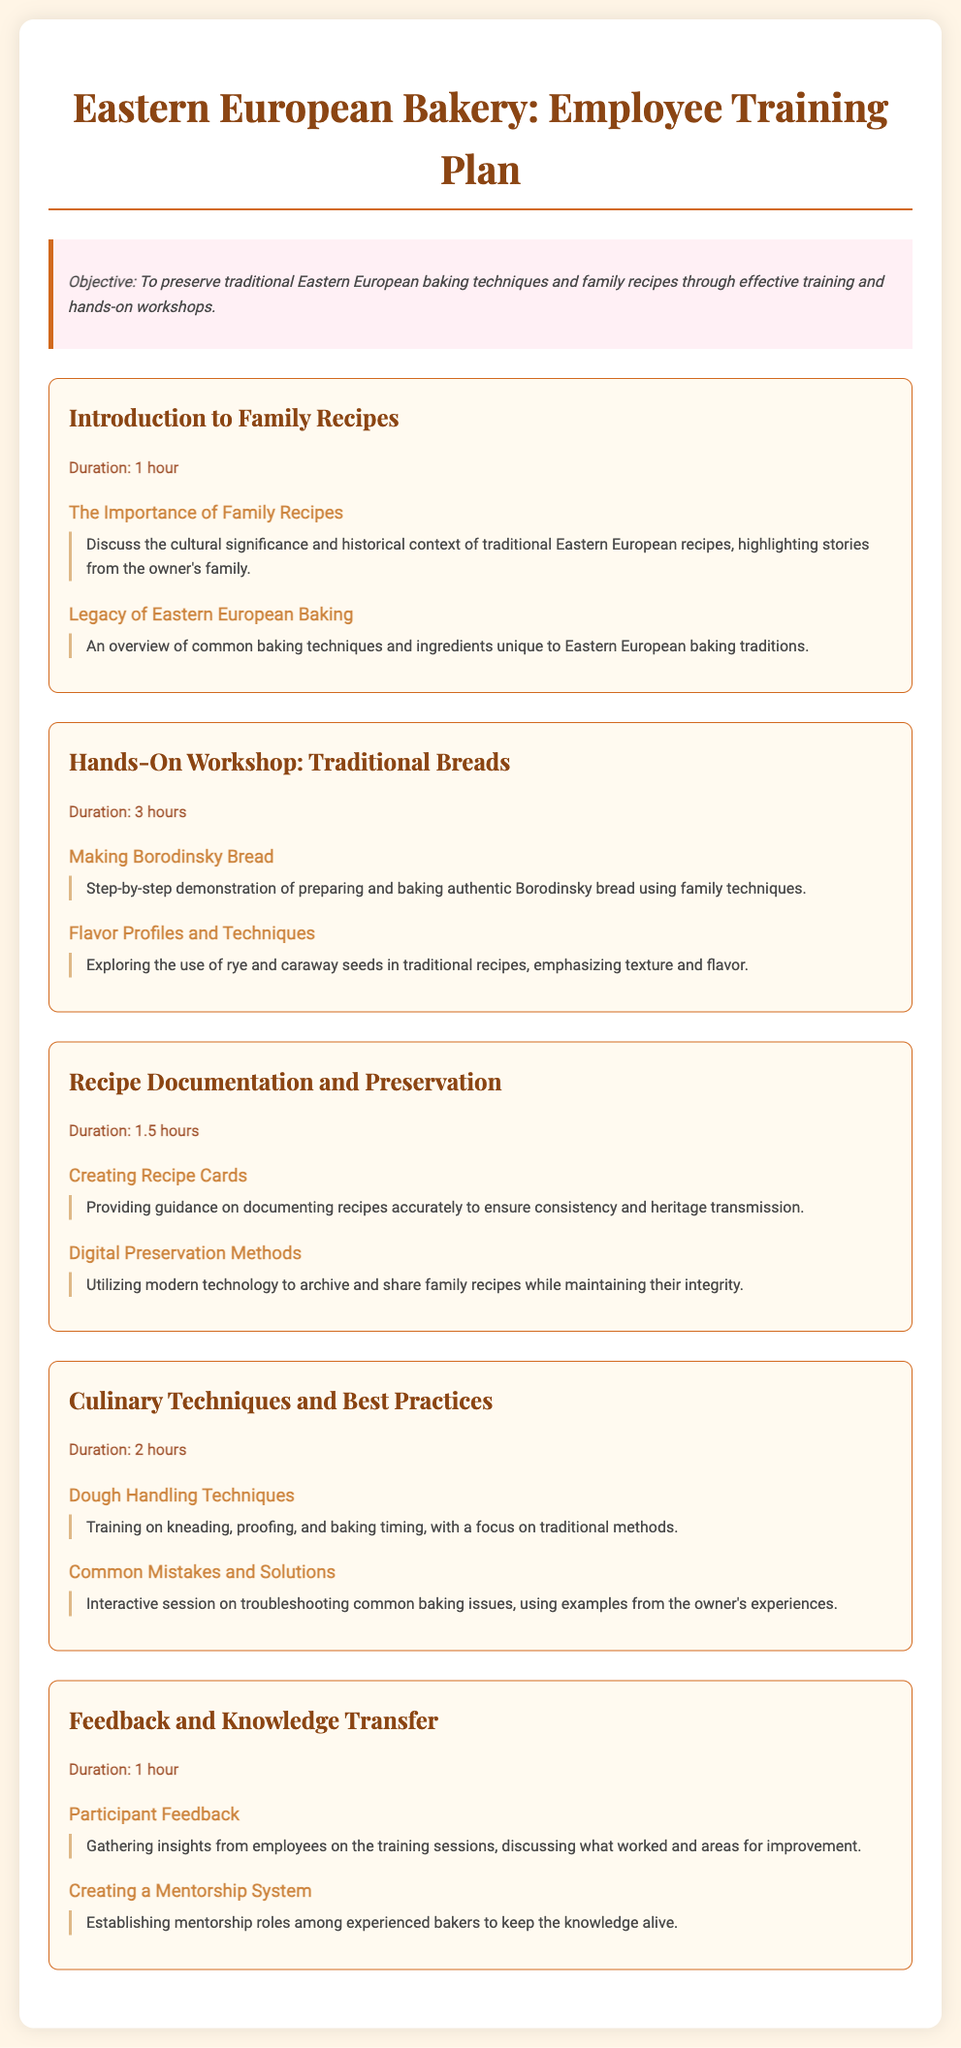What is the objective of the training plan? The objective is stated in the document as "To preserve traditional Eastern European baking techniques and family recipes through effective training and hands-on workshops."
Answer: To preserve traditional Eastern European baking techniques and family recipes through effective training and hands-on workshops How long is the session on Recipe Documentation and Preservation? The duration of the session is listed in the document, which is 1.5 hours.
Answer: 1.5 hours What traditional bread is featured in the hands-on workshop? The document mentions "Borodinsky Bread" as the focus of the traditional breads workshop.
Answer: Borodinsky Bread What culinary technique emphasizes kneading and proofing? The document specifies that "Dough Handling Techniques" focuses on these traditional methods.
Answer: Dough Handling Techniques What is one method of preserving family recipes mentioned? The document lists "Digital Preservation Methods" as a way to archive and share family recipes.
Answer: Digital Preservation Methods What is discussed during the Introduction to Family Recipes session? The document states that it discusses "the cultural significance and historical context of traditional Eastern European recipes."
Answer: The cultural significance and historical context of traditional Eastern European recipes How long is the Feedback and Knowledge Transfer session? The document specifies that this session has a duration of 1 hour.
Answer: 1 hour 